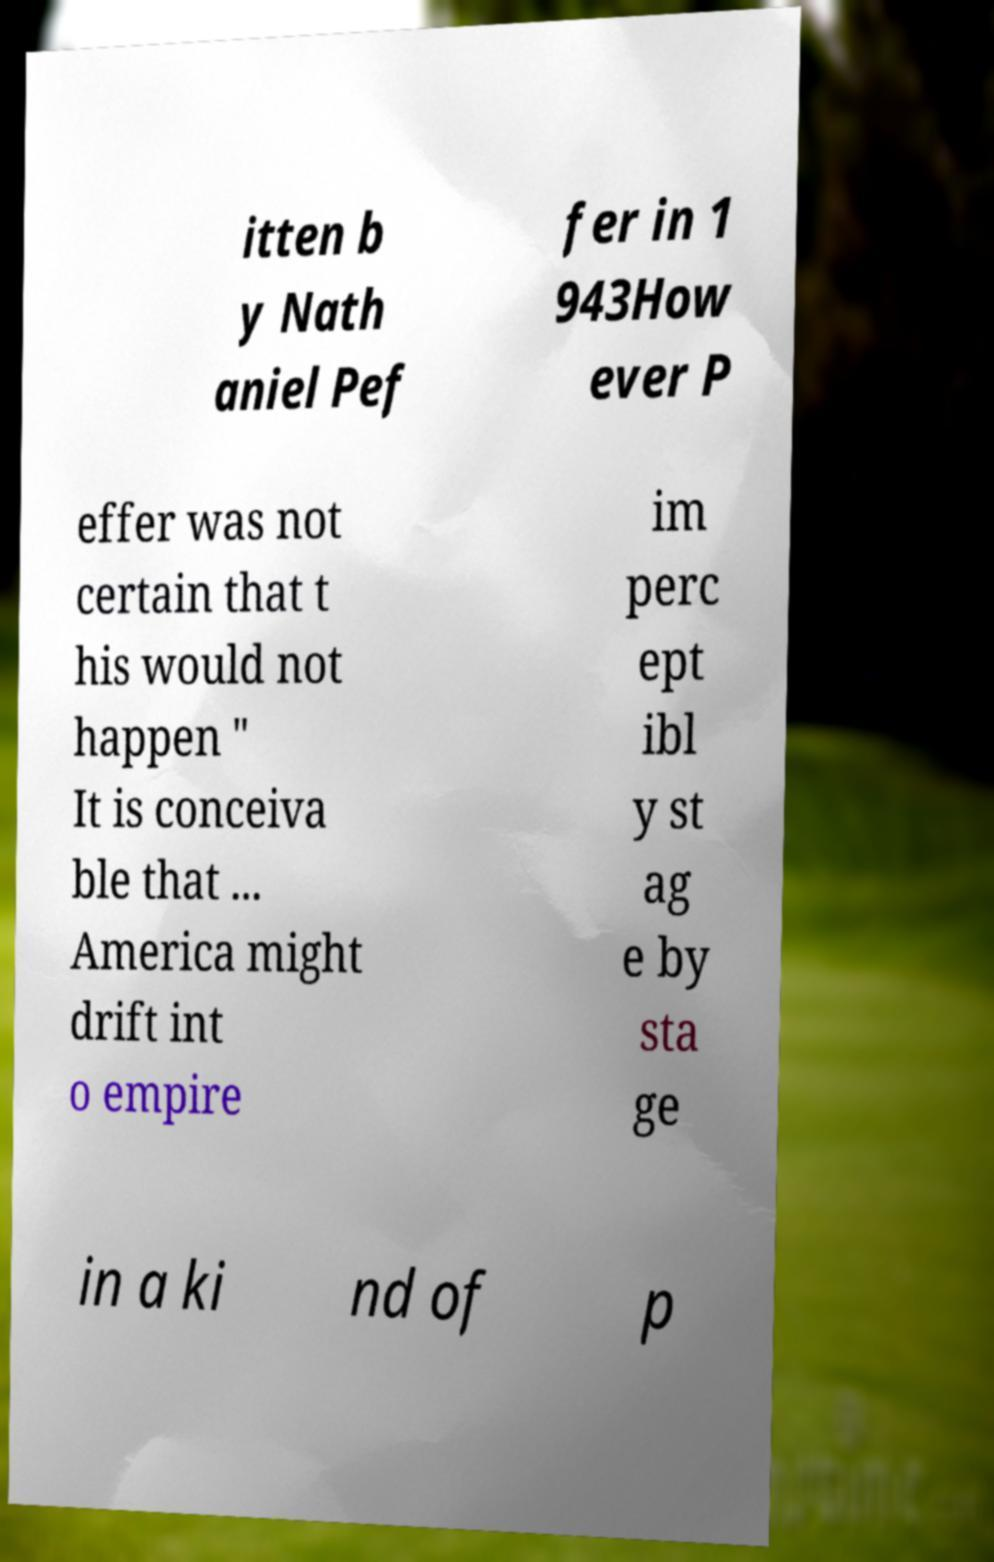There's text embedded in this image that I need extracted. Can you transcribe it verbatim? itten b y Nath aniel Pef fer in 1 943How ever P effer was not certain that t his would not happen " It is conceiva ble that ... America might drift int o empire im perc ept ibl y st ag e by sta ge in a ki nd of p 